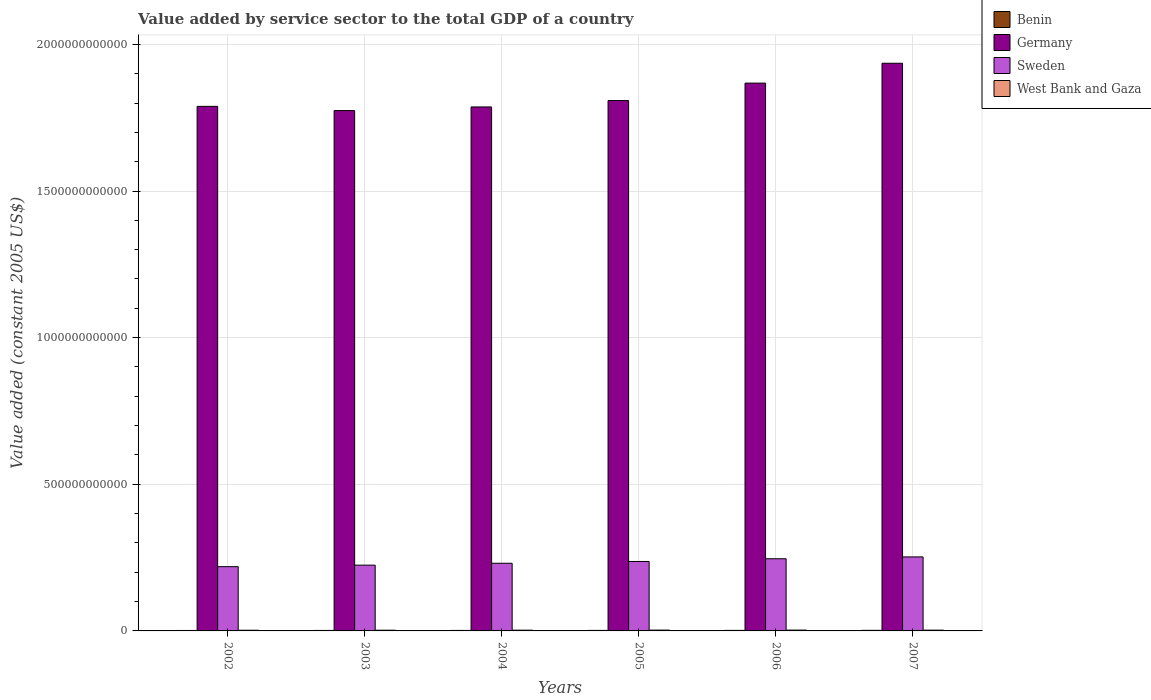Are the number of bars per tick equal to the number of legend labels?
Ensure brevity in your answer.  Yes. How many bars are there on the 6th tick from the right?
Your answer should be very brief. 4. What is the value added by service sector in Benin in 2003?
Keep it short and to the point. 1.67e+09. Across all years, what is the maximum value added by service sector in Benin?
Ensure brevity in your answer.  2.00e+09. Across all years, what is the minimum value added by service sector in Benin?
Make the answer very short. 1.56e+09. In which year was the value added by service sector in Germany minimum?
Give a very brief answer. 2003. What is the total value added by service sector in Germany in the graph?
Ensure brevity in your answer.  1.10e+13. What is the difference between the value added by service sector in West Bank and Gaza in 2002 and that in 2003?
Make the answer very short. -8.51e+07. What is the difference between the value added by service sector in West Bank and Gaza in 2007 and the value added by service sector in Germany in 2005?
Keep it short and to the point. -1.81e+12. What is the average value added by service sector in Benin per year?
Ensure brevity in your answer.  1.77e+09. In the year 2006, what is the difference between the value added by service sector in Sweden and value added by service sector in West Bank and Gaza?
Your answer should be compact. 2.43e+11. In how many years, is the value added by service sector in Germany greater than 1700000000000 US$?
Your answer should be very brief. 6. What is the ratio of the value added by service sector in Benin in 2004 to that in 2006?
Your answer should be compact. 0.94. Is the difference between the value added by service sector in Sweden in 2003 and 2005 greater than the difference between the value added by service sector in West Bank and Gaza in 2003 and 2005?
Your answer should be compact. No. What is the difference between the highest and the second highest value added by service sector in Sweden?
Provide a succinct answer. 6.28e+09. What is the difference between the highest and the lowest value added by service sector in West Bank and Gaza?
Provide a short and direct response. 4.67e+08. In how many years, is the value added by service sector in West Bank and Gaza greater than the average value added by service sector in West Bank and Gaza taken over all years?
Provide a succinct answer. 3. Is the sum of the value added by service sector in West Bank and Gaza in 2003 and 2005 greater than the maximum value added by service sector in Germany across all years?
Your answer should be compact. No. Is it the case that in every year, the sum of the value added by service sector in Sweden and value added by service sector in Benin is greater than the sum of value added by service sector in Germany and value added by service sector in West Bank and Gaza?
Keep it short and to the point. Yes. What does the 1st bar from the left in 2004 represents?
Give a very brief answer. Benin. What does the 4th bar from the right in 2007 represents?
Give a very brief answer. Benin. How many bars are there?
Ensure brevity in your answer.  24. Are all the bars in the graph horizontal?
Offer a terse response. No. What is the difference between two consecutive major ticks on the Y-axis?
Your response must be concise. 5.00e+11. Does the graph contain any zero values?
Your response must be concise. No. Does the graph contain grids?
Your answer should be compact. Yes. Where does the legend appear in the graph?
Offer a very short reply. Top right. What is the title of the graph?
Keep it short and to the point. Value added by service sector to the total GDP of a country. What is the label or title of the X-axis?
Your response must be concise. Years. What is the label or title of the Y-axis?
Make the answer very short. Value added (constant 2005 US$). What is the Value added (constant 2005 US$) of Benin in 2002?
Make the answer very short. 1.56e+09. What is the Value added (constant 2005 US$) of Germany in 2002?
Ensure brevity in your answer.  1.79e+12. What is the Value added (constant 2005 US$) of Sweden in 2002?
Offer a very short reply. 2.19e+11. What is the Value added (constant 2005 US$) in West Bank and Gaza in 2002?
Offer a terse response. 2.34e+09. What is the Value added (constant 2005 US$) of Benin in 2003?
Provide a succinct answer. 1.67e+09. What is the Value added (constant 2005 US$) in Germany in 2003?
Your response must be concise. 1.77e+12. What is the Value added (constant 2005 US$) of Sweden in 2003?
Your answer should be very brief. 2.24e+11. What is the Value added (constant 2005 US$) in West Bank and Gaza in 2003?
Provide a succinct answer. 2.43e+09. What is the Value added (constant 2005 US$) of Benin in 2004?
Your response must be concise. 1.74e+09. What is the Value added (constant 2005 US$) of Germany in 2004?
Make the answer very short. 1.79e+12. What is the Value added (constant 2005 US$) of Sweden in 2004?
Your answer should be compact. 2.31e+11. What is the Value added (constant 2005 US$) of West Bank and Gaza in 2004?
Make the answer very short. 2.55e+09. What is the Value added (constant 2005 US$) of Benin in 2005?
Ensure brevity in your answer.  1.80e+09. What is the Value added (constant 2005 US$) in Germany in 2005?
Offer a terse response. 1.81e+12. What is the Value added (constant 2005 US$) in Sweden in 2005?
Your answer should be compact. 2.37e+11. What is the Value added (constant 2005 US$) in West Bank and Gaza in 2005?
Ensure brevity in your answer.  2.81e+09. What is the Value added (constant 2005 US$) in Benin in 2006?
Give a very brief answer. 1.85e+09. What is the Value added (constant 2005 US$) of Germany in 2006?
Your answer should be very brief. 1.87e+12. What is the Value added (constant 2005 US$) in Sweden in 2006?
Your answer should be compact. 2.46e+11. What is the Value added (constant 2005 US$) in West Bank and Gaza in 2006?
Give a very brief answer. 2.79e+09. What is the Value added (constant 2005 US$) in Benin in 2007?
Provide a short and direct response. 2.00e+09. What is the Value added (constant 2005 US$) of Germany in 2007?
Provide a succinct answer. 1.94e+12. What is the Value added (constant 2005 US$) in Sweden in 2007?
Provide a short and direct response. 2.52e+11. What is the Value added (constant 2005 US$) of West Bank and Gaza in 2007?
Your answer should be compact. 2.63e+09. Across all years, what is the maximum Value added (constant 2005 US$) in Benin?
Give a very brief answer. 2.00e+09. Across all years, what is the maximum Value added (constant 2005 US$) in Germany?
Provide a succinct answer. 1.94e+12. Across all years, what is the maximum Value added (constant 2005 US$) in Sweden?
Give a very brief answer. 2.52e+11. Across all years, what is the maximum Value added (constant 2005 US$) of West Bank and Gaza?
Provide a short and direct response. 2.81e+09. Across all years, what is the minimum Value added (constant 2005 US$) of Benin?
Provide a succinct answer. 1.56e+09. Across all years, what is the minimum Value added (constant 2005 US$) in Germany?
Give a very brief answer. 1.77e+12. Across all years, what is the minimum Value added (constant 2005 US$) of Sweden?
Offer a terse response. 2.19e+11. Across all years, what is the minimum Value added (constant 2005 US$) in West Bank and Gaza?
Ensure brevity in your answer.  2.34e+09. What is the total Value added (constant 2005 US$) of Benin in the graph?
Offer a terse response. 1.06e+1. What is the total Value added (constant 2005 US$) of Germany in the graph?
Offer a terse response. 1.10e+13. What is the total Value added (constant 2005 US$) in Sweden in the graph?
Provide a short and direct response. 1.41e+12. What is the total Value added (constant 2005 US$) of West Bank and Gaza in the graph?
Your answer should be compact. 1.55e+1. What is the difference between the Value added (constant 2005 US$) in Benin in 2002 and that in 2003?
Your answer should be very brief. -1.02e+08. What is the difference between the Value added (constant 2005 US$) of Germany in 2002 and that in 2003?
Make the answer very short. 1.43e+1. What is the difference between the Value added (constant 2005 US$) of Sweden in 2002 and that in 2003?
Offer a very short reply. -5.16e+09. What is the difference between the Value added (constant 2005 US$) in West Bank and Gaza in 2002 and that in 2003?
Keep it short and to the point. -8.51e+07. What is the difference between the Value added (constant 2005 US$) in Benin in 2002 and that in 2004?
Offer a terse response. -1.75e+08. What is the difference between the Value added (constant 2005 US$) in Germany in 2002 and that in 2004?
Give a very brief answer. 2.01e+09. What is the difference between the Value added (constant 2005 US$) of Sweden in 2002 and that in 2004?
Provide a short and direct response. -1.16e+1. What is the difference between the Value added (constant 2005 US$) of West Bank and Gaza in 2002 and that in 2004?
Make the answer very short. -2.08e+08. What is the difference between the Value added (constant 2005 US$) of Benin in 2002 and that in 2005?
Ensure brevity in your answer.  -2.33e+08. What is the difference between the Value added (constant 2005 US$) in Germany in 2002 and that in 2005?
Provide a succinct answer. -1.98e+1. What is the difference between the Value added (constant 2005 US$) in Sweden in 2002 and that in 2005?
Ensure brevity in your answer.  -1.77e+1. What is the difference between the Value added (constant 2005 US$) of West Bank and Gaza in 2002 and that in 2005?
Offer a terse response. -4.67e+08. What is the difference between the Value added (constant 2005 US$) in Benin in 2002 and that in 2006?
Make the answer very short. -2.82e+08. What is the difference between the Value added (constant 2005 US$) of Germany in 2002 and that in 2006?
Give a very brief answer. -7.92e+1. What is the difference between the Value added (constant 2005 US$) of Sweden in 2002 and that in 2006?
Ensure brevity in your answer.  -2.70e+1. What is the difference between the Value added (constant 2005 US$) in West Bank and Gaza in 2002 and that in 2006?
Provide a short and direct response. -4.46e+08. What is the difference between the Value added (constant 2005 US$) in Benin in 2002 and that in 2007?
Keep it short and to the point. -4.40e+08. What is the difference between the Value added (constant 2005 US$) in Germany in 2002 and that in 2007?
Your response must be concise. -1.47e+11. What is the difference between the Value added (constant 2005 US$) in Sweden in 2002 and that in 2007?
Offer a very short reply. -3.33e+1. What is the difference between the Value added (constant 2005 US$) of West Bank and Gaza in 2002 and that in 2007?
Make the answer very short. -2.93e+08. What is the difference between the Value added (constant 2005 US$) in Benin in 2003 and that in 2004?
Ensure brevity in your answer.  -7.22e+07. What is the difference between the Value added (constant 2005 US$) of Germany in 2003 and that in 2004?
Your answer should be compact. -1.23e+1. What is the difference between the Value added (constant 2005 US$) in Sweden in 2003 and that in 2004?
Your response must be concise. -6.45e+09. What is the difference between the Value added (constant 2005 US$) in West Bank and Gaza in 2003 and that in 2004?
Keep it short and to the point. -1.23e+08. What is the difference between the Value added (constant 2005 US$) of Benin in 2003 and that in 2005?
Make the answer very short. -1.31e+08. What is the difference between the Value added (constant 2005 US$) of Germany in 2003 and that in 2005?
Your answer should be compact. -3.42e+1. What is the difference between the Value added (constant 2005 US$) of Sweden in 2003 and that in 2005?
Your response must be concise. -1.25e+1. What is the difference between the Value added (constant 2005 US$) in West Bank and Gaza in 2003 and that in 2005?
Offer a terse response. -3.82e+08. What is the difference between the Value added (constant 2005 US$) of Benin in 2003 and that in 2006?
Provide a short and direct response. -1.80e+08. What is the difference between the Value added (constant 2005 US$) of Germany in 2003 and that in 2006?
Provide a short and direct response. -9.36e+1. What is the difference between the Value added (constant 2005 US$) in Sweden in 2003 and that in 2006?
Your response must be concise. -2.18e+1. What is the difference between the Value added (constant 2005 US$) in West Bank and Gaza in 2003 and that in 2006?
Keep it short and to the point. -3.60e+08. What is the difference between the Value added (constant 2005 US$) in Benin in 2003 and that in 2007?
Your response must be concise. -3.37e+08. What is the difference between the Value added (constant 2005 US$) of Germany in 2003 and that in 2007?
Keep it short and to the point. -1.61e+11. What is the difference between the Value added (constant 2005 US$) of Sweden in 2003 and that in 2007?
Offer a very short reply. -2.81e+1. What is the difference between the Value added (constant 2005 US$) in West Bank and Gaza in 2003 and that in 2007?
Your answer should be compact. -2.08e+08. What is the difference between the Value added (constant 2005 US$) of Benin in 2004 and that in 2005?
Give a very brief answer. -5.87e+07. What is the difference between the Value added (constant 2005 US$) in Germany in 2004 and that in 2005?
Make the answer very short. -2.18e+1. What is the difference between the Value added (constant 2005 US$) of Sweden in 2004 and that in 2005?
Offer a terse response. -6.07e+09. What is the difference between the Value added (constant 2005 US$) of West Bank and Gaza in 2004 and that in 2005?
Provide a short and direct response. -2.59e+08. What is the difference between the Value added (constant 2005 US$) in Benin in 2004 and that in 2006?
Your response must be concise. -1.07e+08. What is the difference between the Value added (constant 2005 US$) in Germany in 2004 and that in 2006?
Provide a succinct answer. -8.13e+1. What is the difference between the Value added (constant 2005 US$) in Sweden in 2004 and that in 2006?
Keep it short and to the point. -1.54e+1. What is the difference between the Value added (constant 2005 US$) of West Bank and Gaza in 2004 and that in 2006?
Offer a terse response. -2.37e+08. What is the difference between the Value added (constant 2005 US$) in Benin in 2004 and that in 2007?
Make the answer very short. -2.65e+08. What is the difference between the Value added (constant 2005 US$) in Germany in 2004 and that in 2007?
Make the answer very short. -1.49e+11. What is the difference between the Value added (constant 2005 US$) in Sweden in 2004 and that in 2007?
Your answer should be compact. -2.16e+1. What is the difference between the Value added (constant 2005 US$) in West Bank and Gaza in 2004 and that in 2007?
Your response must be concise. -8.44e+07. What is the difference between the Value added (constant 2005 US$) in Benin in 2005 and that in 2006?
Keep it short and to the point. -4.87e+07. What is the difference between the Value added (constant 2005 US$) of Germany in 2005 and that in 2006?
Make the answer very short. -5.94e+1. What is the difference between the Value added (constant 2005 US$) in Sweden in 2005 and that in 2006?
Offer a terse response. -9.29e+09. What is the difference between the Value added (constant 2005 US$) in West Bank and Gaza in 2005 and that in 2006?
Offer a very short reply. 2.14e+07. What is the difference between the Value added (constant 2005 US$) of Benin in 2005 and that in 2007?
Ensure brevity in your answer.  -2.06e+08. What is the difference between the Value added (constant 2005 US$) of Germany in 2005 and that in 2007?
Provide a succinct answer. -1.27e+11. What is the difference between the Value added (constant 2005 US$) of Sweden in 2005 and that in 2007?
Your answer should be very brief. -1.56e+1. What is the difference between the Value added (constant 2005 US$) in West Bank and Gaza in 2005 and that in 2007?
Keep it short and to the point. 1.74e+08. What is the difference between the Value added (constant 2005 US$) in Benin in 2006 and that in 2007?
Offer a terse response. -1.58e+08. What is the difference between the Value added (constant 2005 US$) of Germany in 2006 and that in 2007?
Give a very brief answer. -6.77e+1. What is the difference between the Value added (constant 2005 US$) in Sweden in 2006 and that in 2007?
Offer a terse response. -6.28e+09. What is the difference between the Value added (constant 2005 US$) in West Bank and Gaza in 2006 and that in 2007?
Your answer should be very brief. 1.53e+08. What is the difference between the Value added (constant 2005 US$) in Benin in 2002 and the Value added (constant 2005 US$) in Germany in 2003?
Provide a succinct answer. -1.77e+12. What is the difference between the Value added (constant 2005 US$) of Benin in 2002 and the Value added (constant 2005 US$) of Sweden in 2003?
Keep it short and to the point. -2.23e+11. What is the difference between the Value added (constant 2005 US$) of Benin in 2002 and the Value added (constant 2005 US$) of West Bank and Gaza in 2003?
Your answer should be compact. -8.61e+08. What is the difference between the Value added (constant 2005 US$) in Germany in 2002 and the Value added (constant 2005 US$) in Sweden in 2003?
Your answer should be compact. 1.56e+12. What is the difference between the Value added (constant 2005 US$) of Germany in 2002 and the Value added (constant 2005 US$) of West Bank and Gaza in 2003?
Offer a terse response. 1.79e+12. What is the difference between the Value added (constant 2005 US$) of Sweden in 2002 and the Value added (constant 2005 US$) of West Bank and Gaza in 2003?
Keep it short and to the point. 2.17e+11. What is the difference between the Value added (constant 2005 US$) in Benin in 2002 and the Value added (constant 2005 US$) in Germany in 2004?
Ensure brevity in your answer.  -1.79e+12. What is the difference between the Value added (constant 2005 US$) of Benin in 2002 and the Value added (constant 2005 US$) of Sweden in 2004?
Provide a short and direct response. -2.29e+11. What is the difference between the Value added (constant 2005 US$) in Benin in 2002 and the Value added (constant 2005 US$) in West Bank and Gaza in 2004?
Keep it short and to the point. -9.84e+08. What is the difference between the Value added (constant 2005 US$) of Germany in 2002 and the Value added (constant 2005 US$) of Sweden in 2004?
Your answer should be compact. 1.56e+12. What is the difference between the Value added (constant 2005 US$) in Germany in 2002 and the Value added (constant 2005 US$) in West Bank and Gaza in 2004?
Your response must be concise. 1.79e+12. What is the difference between the Value added (constant 2005 US$) of Sweden in 2002 and the Value added (constant 2005 US$) of West Bank and Gaza in 2004?
Your response must be concise. 2.17e+11. What is the difference between the Value added (constant 2005 US$) of Benin in 2002 and the Value added (constant 2005 US$) of Germany in 2005?
Make the answer very short. -1.81e+12. What is the difference between the Value added (constant 2005 US$) of Benin in 2002 and the Value added (constant 2005 US$) of Sweden in 2005?
Offer a terse response. -2.35e+11. What is the difference between the Value added (constant 2005 US$) of Benin in 2002 and the Value added (constant 2005 US$) of West Bank and Gaza in 2005?
Provide a short and direct response. -1.24e+09. What is the difference between the Value added (constant 2005 US$) in Germany in 2002 and the Value added (constant 2005 US$) in Sweden in 2005?
Your answer should be very brief. 1.55e+12. What is the difference between the Value added (constant 2005 US$) in Germany in 2002 and the Value added (constant 2005 US$) in West Bank and Gaza in 2005?
Offer a terse response. 1.79e+12. What is the difference between the Value added (constant 2005 US$) in Sweden in 2002 and the Value added (constant 2005 US$) in West Bank and Gaza in 2005?
Your response must be concise. 2.16e+11. What is the difference between the Value added (constant 2005 US$) in Benin in 2002 and the Value added (constant 2005 US$) in Germany in 2006?
Offer a terse response. -1.87e+12. What is the difference between the Value added (constant 2005 US$) in Benin in 2002 and the Value added (constant 2005 US$) in Sweden in 2006?
Ensure brevity in your answer.  -2.45e+11. What is the difference between the Value added (constant 2005 US$) of Benin in 2002 and the Value added (constant 2005 US$) of West Bank and Gaza in 2006?
Offer a very short reply. -1.22e+09. What is the difference between the Value added (constant 2005 US$) of Germany in 2002 and the Value added (constant 2005 US$) of Sweden in 2006?
Provide a short and direct response. 1.54e+12. What is the difference between the Value added (constant 2005 US$) in Germany in 2002 and the Value added (constant 2005 US$) in West Bank and Gaza in 2006?
Provide a short and direct response. 1.79e+12. What is the difference between the Value added (constant 2005 US$) of Sweden in 2002 and the Value added (constant 2005 US$) of West Bank and Gaza in 2006?
Provide a short and direct response. 2.16e+11. What is the difference between the Value added (constant 2005 US$) of Benin in 2002 and the Value added (constant 2005 US$) of Germany in 2007?
Offer a terse response. -1.93e+12. What is the difference between the Value added (constant 2005 US$) of Benin in 2002 and the Value added (constant 2005 US$) of Sweden in 2007?
Give a very brief answer. -2.51e+11. What is the difference between the Value added (constant 2005 US$) of Benin in 2002 and the Value added (constant 2005 US$) of West Bank and Gaza in 2007?
Your answer should be very brief. -1.07e+09. What is the difference between the Value added (constant 2005 US$) in Germany in 2002 and the Value added (constant 2005 US$) in Sweden in 2007?
Provide a succinct answer. 1.54e+12. What is the difference between the Value added (constant 2005 US$) of Germany in 2002 and the Value added (constant 2005 US$) of West Bank and Gaza in 2007?
Offer a very short reply. 1.79e+12. What is the difference between the Value added (constant 2005 US$) of Sweden in 2002 and the Value added (constant 2005 US$) of West Bank and Gaza in 2007?
Provide a short and direct response. 2.16e+11. What is the difference between the Value added (constant 2005 US$) in Benin in 2003 and the Value added (constant 2005 US$) in Germany in 2004?
Make the answer very short. -1.78e+12. What is the difference between the Value added (constant 2005 US$) in Benin in 2003 and the Value added (constant 2005 US$) in Sweden in 2004?
Provide a succinct answer. -2.29e+11. What is the difference between the Value added (constant 2005 US$) of Benin in 2003 and the Value added (constant 2005 US$) of West Bank and Gaza in 2004?
Keep it short and to the point. -8.82e+08. What is the difference between the Value added (constant 2005 US$) in Germany in 2003 and the Value added (constant 2005 US$) in Sweden in 2004?
Your response must be concise. 1.54e+12. What is the difference between the Value added (constant 2005 US$) in Germany in 2003 and the Value added (constant 2005 US$) in West Bank and Gaza in 2004?
Make the answer very short. 1.77e+12. What is the difference between the Value added (constant 2005 US$) in Sweden in 2003 and the Value added (constant 2005 US$) in West Bank and Gaza in 2004?
Keep it short and to the point. 2.22e+11. What is the difference between the Value added (constant 2005 US$) of Benin in 2003 and the Value added (constant 2005 US$) of Germany in 2005?
Make the answer very short. -1.81e+12. What is the difference between the Value added (constant 2005 US$) of Benin in 2003 and the Value added (constant 2005 US$) of Sweden in 2005?
Your answer should be very brief. -2.35e+11. What is the difference between the Value added (constant 2005 US$) in Benin in 2003 and the Value added (constant 2005 US$) in West Bank and Gaza in 2005?
Provide a succinct answer. -1.14e+09. What is the difference between the Value added (constant 2005 US$) of Germany in 2003 and the Value added (constant 2005 US$) of Sweden in 2005?
Provide a succinct answer. 1.54e+12. What is the difference between the Value added (constant 2005 US$) of Germany in 2003 and the Value added (constant 2005 US$) of West Bank and Gaza in 2005?
Ensure brevity in your answer.  1.77e+12. What is the difference between the Value added (constant 2005 US$) of Sweden in 2003 and the Value added (constant 2005 US$) of West Bank and Gaza in 2005?
Keep it short and to the point. 2.21e+11. What is the difference between the Value added (constant 2005 US$) of Benin in 2003 and the Value added (constant 2005 US$) of Germany in 2006?
Your answer should be very brief. -1.87e+12. What is the difference between the Value added (constant 2005 US$) in Benin in 2003 and the Value added (constant 2005 US$) in Sweden in 2006?
Provide a succinct answer. -2.44e+11. What is the difference between the Value added (constant 2005 US$) of Benin in 2003 and the Value added (constant 2005 US$) of West Bank and Gaza in 2006?
Your answer should be very brief. -1.12e+09. What is the difference between the Value added (constant 2005 US$) of Germany in 2003 and the Value added (constant 2005 US$) of Sweden in 2006?
Ensure brevity in your answer.  1.53e+12. What is the difference between the Value added (constant 2005 US$) in Germany in 2003 and the Value added (constant 2005 US$) in West Bank and Gaza in 2006?
Provide a succinct answer. 1.77e+12. What is the difference between the Value added (constant 2005 US$) in Sweden in 2003 and the Value added (constant 2005 US$) in West Bank and Gaza in 2006?
Offer a terse response. 2.21e+11. What is the difference between the Value added (constant 2005 US$) of Benin in 2003 and the Value added (constant 2005 US$) of Germany in 2007?
Your answer should be compact. -1.93e+12. What is the difference between the Value added (constant 2005 US$) of Benin in 2003 and the Value added (constant 2005 US$) of Sweden in 2007?
Your answer should be compact. -2.51e+11. What is the difference between the Value added (constant 2005 US$) of Benin in 2003 and the Value added (constant 2005 US$) of West Bank and Gaza in 2007?
Make the answer very short. -9.66e+08. What is the difference between the Value added (constant 2005 US$) of Germany in 2003 and the Value added (constant 2005 US$) of Sweden in 2007?
Your answer should be very brief. 1.52e+12. What is the difference between the Value added (constant 2005 US$) in Germany in 2003 and the Value added (constant 2005 US$) in West Bank and Gaza in 2007?
Your answer should be compact. 1.77e+12. What is the difference between the Value added (constant 2005 US$) of Sweden in 2003 and the Value added (constant 2005 US$) of West Bank and Gaza in 2007?
Offer a very short reply. 2.22e+11. What is the difference between the Value added (constant 2005 US$) in Benin in 2004 and the Value added (constant 2005 US$) in Germany in 2005?
Keep it short and to the point. -1.81e+12. What is the difference between the Value added (constant 2005 US$) in Benin in 2004 and the Value added (constant 2005 US$) in Sweden in 2005?
Give a very brief answer. -2.35e+11. What is the difference between the Value added (constant 2005 US$) in Benin in 2004 and the Value added (constant 2005 US$) in West Bank and Gaza in 2005?
Your answer should be very brief. -1.07e+09. What is the difference between the Value added (constant 2005 US$) of Germany in 2004 and the Value added (constant 2005 US$) of Sweden in 2005?
Provide a succinct answer. 1.55e+12. What is the difference between the Value added (constant 2005 US$) of Germany in 2004 and the Value added (constant 2005 US$) of West Bank and Gaza in 2005?
Give a very brief answer. 1.78e+12. What is the difference between the Value added (constant 2005 US$) in Sweden in 2004 and the Value added (constant 2005 US$) in West Bank and Gaza in 2005?
Provide a short and direct response. 2.28e+11. What is the difference between the Value added (constant 2005 US$) in Benin in 2004 and the Value added (constant 2005 US$) in Germany in 2006?
Make the answer very short. -1.87e+12. What is the difference between the Value added (constant 2005 US$) of Benin in 2004 and the Value added (constant 2005 US$) of Sweden in 2006?
Offer a terse response. -2.44e+11. What is the difference between the Value added (constant 2005 US$) of Benin in 2004 and the Value added (constant 2005 US$) of West Bank and Gaza in 2006?
Your answer should be very brief. -1.05e+09. What is the difference between the Value added (constant 2005 US$) in Germany in 2004 and the Value added (constant 2005 US$) in Sweden in 2006?
Your answer should be very brief. 1.54e+12. What is the difference between the Value added (constant 2005 US$) of Germany in 2004 and the Value added (constant 2005 US$) of West Bank and Gaza in 2006?
Make the answer very short. 1.78e+12. What is the difference between the Value added (constant 2005 US$) in Sweden in 2004 and the Value added (constant 2005 US$) in West Bank and Gaza in 2006?
Provide a short and direct response. 2.28e+11. What is the difference between the Value added (constant 2005 US$) in Benin in 2004 and the Value added (constant 2005 US$) in Germany in 2007?
Your answer should be very brief. -1.93e+12. What is the difference between the Value added (constant 2005 US$) in Benin in 2004 and the Value added (constant 2005 US$) in Sweden in 2007?
Your response must be concise. -2.51e+11. What is the difference between the Value added (constant 2005 US$) in Benin in 2004 and the Value added (constant 2005 US$) in West Bank and Gaza in 2007?
Provide a short and direct response. -8.94e+08. What is the difference between the Value added (constant 2005 US$) in Germany in 2004 and the Value added (constant 2005 US$) in Sweden in 2007?
Your answer should be compact. 1.53e+12. What is the difference between the Value added (constant 2005 US$) of Germany in 2004 and the Value added (constant 2005 US$) of West Bank and Gaza in 2007?
Make the answer very short. 1.78e+12. What is the difference between the Value added (constant 2005 US$) of Sweden in 2004 and the Value added (constant 2005 US$) of West Bank and Gaza in 2007?
Your answer should be compact. 2.28e+11. What is the difference between the Value added (constant 2005 US$) of Benin in 2005 and the Value added (constant 2005 US$) of Germany in 2006?
Make the answer very short. -1.87e+12. What is the difference between the Value added (constant 2005 US$) in Benin in 2005 and the Value added (constant 2005 US$) in Sweden in 2006?
Provide a succinct answer. -2.44e+11. What is the difference between the Value added (constant 2005 US$) in Benin in 2005 and the Value added (constant 2005 US$) in West Bank and Gaza in 2006?
Keep it short and to the point. -9.88e+08. What is the difference between the Value added (constant 2005 US$) in Germany in 2005 and the Value added (constant 2005 US$) in Sweden in 2006?
Offer a terse response. 1.56e+12. What is the difference between the Value added (constant 2005 US$) of Germany in 2005 and the Value added (constant 2005 US$) of West Bank and Gaza in 2006?
Provide a succinct answer. 1.81e+12. What is the difference between the Value added (constant 2005 US$) of Sweden in 2005 and the Value added (constant 2005 US$) of West Bank and Gaza in 2006?
Your answer should be very brief. 2.34e+11. What is the difference between the Value added (constant 2005 US$) in Benin in 2005 and the Value added (constant 2005 US$) in Germany in 2007?
Make the answer very short. -1.93e+12. What is the difference between the Value added (constant 2005 US$) of Benin in 2005 and the Value added (constant 2005 US$) of Sweden in 2007?
Give a very brief answer. -2.51e+11. What is the difference between the Value added (constant 2005 US$) of Benin in 2005 and the Value added (constant 2005 US$) of West Bank and Gaza in 2007?
Ensure brevity in your answer.  -8.35e+08. What is the difference between the Value added (constant 2005 US$) in Germany in 2005 and the Value added (constant 2005 US$) in Sweden in 2007?
Your answer should be compact. 1.56e+12. What is the difference between the Value added (constant 2005 US$) of Germany in 2005 and the Value added (constant 2005 US$) of West Bank and Gaza in 2007?
Ensure brevity in your answer.  1.81e+12. What is the difference between the Value added (constant 2005 US$) in Sweden in 2005 and the Value added (constant 2005 US$) in West Bank and Gaza in 2007?
Make the answer very short. 2.34e+11. What is the difference between the Value added (constant 2005 US$) of Benin in 2006 and the Value added (constant 2005 US$) of Germany in 2007?
Give a very brief answer. -1.93e+12. What is the difference between the Value added (constant 2005 US$) of Benin in 2006 and the Value added (constant 2005 US$) of Sweden in 2007?
Offer a very short reply. -2.51e+11. What is the difference between the Value added (constant 2005 US$) of Benin in 2006 and the Value added (constant 2005 US$) of West Bank and Gaza in 2007?
Give a very brief answer. -7.87e+08. What is the difference between the Value added (constant 2005 US$) of Germany in 2006 and the Value added (constant 2005 US$) of Sweden in 2007?
Give a very brief answer. 1.62e+12. What is the difference between the Value added (constant 2005 US$) in Germany in 2006 and the Value added (constant 2005 US$) in West Bank and Gaza in 2007?
Provide a short and direct response. 1.87e+12. What is the difference between the Value added (constant 2005 US$) of Sweden in 2006 and the Value added (constant 2005 US$) of West Bank and Gaza in 2007?
Give a very brief answer. 2.43e+11. What is the average Value added (constant 2005 US$) in Benin per year?
Make the answer very short. 1.77e+09. What is the average Value added (constant 2005 US$) in Germany per year?
Your response must be concise. 1.83e+12. What is the average Value added (constant 2005 US$) in Sweden per year?
Your answer should be very brief. 2.35e+11. What is the average Value added (constant 2005 US$) of West Bank and Gaza per year?
Make the answer very short. 2.59e+09. In the year 2002, what is the difference between the Value added (constant 2005 US$) in Benin and Value added (constant 2005 US$) in Germany?
Provide a succinct answer. -1.79e+12. In the year 2002, what is the difference between the Value added (constant 2005 US$) in Benin and Value added (constant 2005 US$) in Sweden?
Your response must be concise. -2.18e+11. In the year 2002, what is the difference between the Value added (constant 2005 US$) in Benin and Value added (constant 2005 US$) in West Bank and Gaza?
Offer a terse response. -7.76e+08. In the year 2002, what is the difference between the Value added (constant 2005 US$) of Germany and Value added (constant 2005 US$) of Sweden?
Provide a succinct answer. 1.57e+12. In the year 2002, what is the difference between the Value added (constant 2005 US$) in Germany and Value added (constant 2005 US$) in West Bank and Gaza?
Offer a very short reply. 1.79e+12. In the year 2002, what is the difference between the Value added (constant 2005 US$) in Sweden and Value added (constant 2005 US$) in West Bank and Gaza?
Your answer should be compact. 2.17e+11. In the year 2003, what is the difference between the Value added (constant 2005 US$) of Benin and Value added (constant 2005 US$) of Germany?
Provide a succinct answer. -1.77e+12. In the year 2003, what is the difference between the Value added (constant 2005 US$) in Benin and Value added (constant 2005 US$) in Sweden?
Provide a short and direct response. -2.23e+11. In the year 2003, what is the difference between the Value added (constant 2005 US$) of Benin and Value added (constant 2005 US$) of West Bank and Gaza?
Offer a very short reply. -7.59e+08. In the year 2003, what is the difference between the Value added (constant 2005 US$) in Germany and Value added (constant 2005 US$) in Sweden?
Keep it short and to the point. 1.55e+12. In the year 2003, what is the difference between the Value added (constant 2005 US$) in Germany and Value added (constant 2005 US$) in West Bank and Gaza?
Offer a very short reply. 1.77e+12. In the year 2003, what is the difference between the Value added (constant 2005 US$) in Sweden and Value added (constant 2005 US$) in West Bank and Gaza?
Ensure brevity in your answer.  2.22e+11. In the year 2004, what is the difference between the Value added (constant 2005 US$) of Benin and Value added (constant 2005 US$) of Germany?
Keep it short and to the point. -1.78e+12. In the year 2004, what is the difference between the Value added (constant 2005 US$) of Benin and Value added (constant 2005 US$) of Sweden?
Keep it short and to the point. -2.29e+11. In the year 2004, what is the difference between the Value added (constant 2005 US$) of Benin and Value added (constant 2005 US$) of West Bank and Gaza?
Keep it short and to the point. -8.10e+08. In the year 2004, what is the difference between the Value added (constant 2005 US$) in Germany and Value added (constant 2005 US$) in Sweden?
Your answer should be compact. 1.56e+12. In the year 2004, what is the difference between the Value added (constant 2005 US$) in Germany and Value added (constant 2005 US$) in West Bank and Gaza?
Your answer should be compact. 1.78e+12. In the year 2004, what is the difference between the Value added (constant 2005 US$) in Sweden and Value added (constant 2005 US$) in West Bank and Gaza?
Your response must be concise. 2.28e+11. In the year 2005, what is the difference between the Value added (constant 2005 US$) in Benin and Value added (constant 2005 US$) in Germany?
Make the answer very short. -1.81e+12. In the year 2005, what is the difference between the Value added (constant 2005 US$) in Benin and Value added (constant 2005 US$) in Sweden?
Provide a succinct answer. -2.35e+11. In the year 2005, what is the difference between the Value added (constant 2005 US$) in Benin and Value added (constant 2005 US$) in West Bank and Gaza?
Ensure brevity in your answer.  -1.01e+09. In the year 2005, what is the difference between the Value added (constant 2005 US$) in Germany and Value added (constant 2005 US$) in Sweden?
Your response must be concise. 1.57e+12. In the year 2005, what is the difference between the Value added (constant 2005 US$) of Germany and Value added (constant 2005 US$) of West Bank and Gaza?
Give a very brief answer. 1.81e+12. In the year 2005, what is the difference between the Value added (constant 2005 US$) of Sweden and Value added (constant 2005 US$) of West Bank and Gaza?
Make the answer very short. 2.34e+11. In the year 2006, what is the difference between the Value added (constant 2005 US$) in Benin and Value added (constant 2005 US$) in Germany?
Your answer should be very brief. -1.87e+12. In the year 2006, what is the difference between the Value added (constant 2005 US$) of Benin and Value added (constant 2005 US$) of Sweden?
Make the answer very short. -2.44e+11. In the year 2006, what is the difference between the Value added (constant 2005 US$) of Benin and Value added (constant 2005 US$) of West Bank and Gaza?
Your answer should be compact. -9.39e+08. In the year 2006, what is the difference between the Value added (constant 2005 US$) in Germany and Value added (constant 2005 US$) in Sweden?
Offer a very short reply. 1.62e+12. In the year 2006, what is the difference between the Value added (constant 2005 US$) of Germany and Value added (constant 2005 US$) of West Bank and Gaza?
Ensure brevity in your answer.  1.87e+12. In the year 2006, what is the difference between the Value added (constant 2005 US$) in Sweden and Value added (constant 2005 US$) in West Bank and Gaza?
Your response must be concise. 2.43e+11. In the year 2007, what is the difference between the Value added (constant 2005 US$) of Benin and Value added (constant 2005 US$) of Germany?
Give a very brief answer. -1.93e+12. In the year 2007, what is the difference between the Value added (constant 2005 US$) of Benin and Value added (constant 2005 US$) of Sweden?
Offer a terse response. -2.50e+11. In the year 2007, what is the difference between the Value added (constant 2005 US$) in Benin and Value added (constant 2005 US$) in West Bank and Gaza?
Provide a succinct answer. -6.29e+08. In the year 2007, what is the difference between the Value added (constant 2005 US$) of Germany and Value added (constant 2005 US$) of Sweden?
Provide a succinct answer. 1.68e+12. In the year 2007, what is the difference between the Value added (constant 2005 US$) of Germany and Value added (constant 2005 US$) of West Bank and Gaza?
Provide a short and direct response. 1.93e+12. In the year 2007, what is the difference between the Value added (constant 2005 US$) in Sweden and Value added (constant 2005 US$) in West Bank and Gaza?
Provide a succinct answer. 2.50e+11. What is the ratio of the Value added (constant 2005 US$) in Benin in 2002 to that in 2003?
Give a very brief answer. 0.94. What is the ratio of the Value added (constant 2005 US$) in Sweden in 2002 to that in 2003?
Offer a very short reply. 0.98. What is the ratio of the Value added (constant 2005 US$) in West Bank and Gaza in 2002 to that in 2003?
Offer a terse response. 0.96. What is the ratio of the Value added (constant 2005 US$) in Benin in 2002 to that in 2004?
Make the answer very short. 0.9. What is the ratio of the Value added (constant 2005 US$) in Germany in 2002 to that in 2004?
Provide a succinct answer. 1. What is the ratio of the Value added (constant 2005 US$) of Sweden in 2002 to that in 2004?
Provide a short and direct response. 0.95. What is the ratio of the Value added (constant 2005 US$) in West Bank and Gaza in 2002 to that in 2004?
Your answer should be very brief. 0.92. What is the ratio of the Value added (constant 2005 US$) of Benin in 2002 to that in 2005?
Give a very brief answer. 0.87. What is the ratio of the Value added (constant 2005 US$) in Germany in 2002 to that in 2005?
Offer a terse response. 0.99. What is the ratio of the Value added (constant 2005 US$) in Sweden in 2002 to that in 2005?
Keep it short and to the point. 0.93. What is the ratio of the Value added (constant 2005 US$) in West Bank and Gaza in 2002 to that in 2005?
Give a very brief answer. 0.83. What is the ratio of the Value added (constant 2005 US$) of Benin in 2002 to that in 2006?
Provide a short and direct response. 0.85. What is the ratio of the Value added (constant 2005 US$) in Germany in 2002 to that in 2006?
Provide a short and direct response. 0.96. What is the ratio of the Value added (constant 2005 US$) of Sweden in 2002 to that in 2006?
Provide a succinct answer. 0.89. What is the ratio of the Value added (constant 2005 US$) in West Bank and Gaza in 2002 to that in 2006?
Provide a succinct answer. 0.84. What is the ratio of the Value added (constant 2005 US$) in Benin in 2002 to that in 2007?
Ensure brevity in your answer.  0.78. What is the ratio of the Value added (constant 2005 US$) of Germany in 2002 to that in 2007?
Keep it short and to the point. 0.92. What is the ratio of the Value added (constant 2005 US$) in Sweden in 2002 to that in 2007?
Your answer should be compact. 0.87. What is the ratio of the Value added (constant 2005 US$) of West Bank and Gaza in 2002 to that in 2007?
Offer a very short reply. 0.89. What is the ratio of the Value added (constant 2005 US$) in Benin in 2003 to that in 2004?
Offer a very short reply. 0.96. What is the ratio of the Value added (constant 2005 US$) in Germany in 2003 to that in 2004?
Offer a terse response. 0.99. What is the ratio of the Value added (constant 2005 US$) of Sweden in 2003 to that in 2004?
Provide a succinct answer. 0.97. What is the ratio of the Value added (constant 2005 US$) of West Bank and Gaza in 2003 to that in 2004?
Your answer should be compact. 0.95. What is the ratio of the Value added (constant 2005 US$) of Benin in 2003 to that in 2005?
Give a very brief answer. 0.93. What is the ratio of the Value added (constant 2005 US$) in Germany in 2003 to that in 2005?
Make the answer very short. 0.98. What is the ratio of the Value added (constant 2005 US$) of Sweden in 2003 to that in 2005?
Provide a succinct answer. 0.95. What is the ratio of the Value added (constant 2005 US$) in West Bank and Gaza in 2003 to that in 2005?
Your answer should be compact. 0.86. What is the ratio of the Value added (constant 2005 US$) of Benin in 2003 to that in 2006?
Ensure brevity in your answer.  0.9. What is the ratio of the Value added (constant 2005 US$) of Germany in 2003 to that in 2006?
Your answer should be very brief. 0.95. What is the ratio of the Value added (constant 2005 US$) in Sweden in 2003 to that in 2006?
Offer a terse response. 0.91. What is the ratio of the Value added (constant 2005 US$) of West Bank and Gaza in 2003 to that in 2006?
Offer a terse response. 0.87. What is the ratio of the Value added (constant 2005 US$) of Benin in 2003 to that in 2007?
Your answer should be very brief. 0.83. What is the ratio of the Value added (constant 2005 US$) in Sweden in 2003 to that in 2007?
Provide a short and direct response. 0.89. What is the ratio of the Value added (constant 2005 US$) of West Bank and Gaza in 2003 to that in 2007?
Make the answer very short. 0.92. What is the ratio of the Value added (constant 2005 US$) of Benin in 2004 to that in 2005?
Provide a short and direct response. 0.97. What is the ratio of the Value added (constant 2005 US$) in Germany in 2004 to that in 2005?
Provide a succinct answer. 0.99. What is the ratio of the Value added (constant 2005 US$) in Sweden in 2004 to that in 2005?
Provide a short and direct response. 0.97. What is the ratio of the Value added (constant 2005 US$) of West Bank and Gaza in 2004 to that in 2005?
Make the answer very short. 0.91. What is the ratio of the Value added (constant 2005 US$) in Benin in 2004 to that in 2006?
Provide a succinct answer. 0.94. What is the ratio of the Value added (constant 2005 US$) in Germany in 2004 to that in 2006?
Ensure brevity in your answer.  0.96. What is the ratio of the Value added (constant 2005 US$) of Sweden in 2004 to that in 2006?
Your answer should be very brief. 0.94. What is the ratio of the Value added (constant 2005 US$) in West Bank and Gaza in 2004 to that in 2006?
Your answer should be compact. 0.91. What is the ratio of the Value added (constant 2005 US$) of Benin in 2004 to that in 2007?
Provide a short and direct response. 0.87. What is the ratio of the Value added (constant 2005 US$) of Germany in 2004 to that in 2007?
Give a very brief answer. 0.92. What is the ratio of the Value added (constant 2005 US$) of Sweden in 2004 to that in 2007?
Provide a short and direct response. 0.91. What is the ratio of the Value added (constant 2005 US$) of West Bank and Gaza in 2004 to that in 2007?
Give a very brief answer. 0.97. What is the ratio of the Value added (constant 2005 US$) in Benin in 2005 to that in 2006?
Your answer should be very brief. 0.97. What is the ratio of the Value added (constant 2005 US$) in Germany in 2005 to that in 2006?
Give a very brief answer. 0.97. What is the ratio of the Value added (constant 2005 US$) of Sweden in 2005 to that in 2006?
Make the answer very short. 0.96. What is the ratio of the Value added (constant 2005 US$) of West Bank and Gaza in 2005 to that in 2006?
Give a very brief answer. 1.01. What is the ratio of the Value added (constant 2005 US$) in Benin in 2005 to that in 2007?
Make the answer very short. 0.9. What is the ratio of the Value added (constant 2005 US$) of Germany in 2005 to that in 2007?
Make the answer very short. 0.93. What is the ratio of the Value added (constant 2005 US$) of Sweden in 2005 to that in 2007?
Your answer should be compact. 0.94. What is the ratio of the Value added (constant 2005 US$) of West Bank and Gaza in 2005 to that in 2007?
Provide a short and direct response. 1.07. What is the ratio of the Value added (constant 2005 US$) of Benin in 2006 to that in 2007?
Provide a succinct answer. 0.92. What is the ratio of the Value added (constant 2005 US$) in Sweden in 2006 to that in 2007?
Your answer should be very brief. 0.98. What is the ratio of the Value added (constant 2005 US$) of West Bank and Gaza in 2006 to that in 2007?
Keep it short and to the point. 1.06. What is the difference between the highest and the second highest Value added (constant 2005 US$) in Benin?
Ensure brevity in your answer.  1.58e+08. What is the difference between the highest and the second highest Value added (constant 2005 US$) in Germany?
Provide a short and direct response. 6.77e+1. What is the difference between the highest and the second highest Value added (constant 2005 US$) of Sweden?
Your response must be concise. 6.28e+09. What is the difference between the highest and the second highest Value added (constant 2005 US$) of West Bank and Gaza?
Offer a very short reply. 2.14e+07. What is the difference between the highest and the lowest Value added (constant 2005 US$) in Benin?
Provide a short and direct response. 4.40e+08. What is the difference between the highest and the lowest Value added (constant 2005 US$) in Germany?
Your answer should be compact. 1.61e+11. What is the difference between the highest and the lowest Value added (constant 2005 US$) in Sweden?
Offer a terse response. 3.33e+1. What is the difference between the highest and the lowest Value added (constant 2005 US$) of West Bank and Gaza?
Keep it short and to the point. 4.67e+08. 